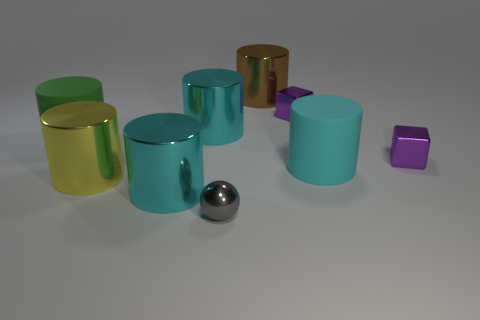Subtract all red blocks. How many cyan cylinders are left? 3 Subtract all brown cylinders. How many cylinders are left? 5 Subtract all large brown cylinders. How many cylinders are left? 5 Subtract all blue cylinders. Subtract all brown balls. How many cylinders are left? 6 Add 1 green objects. How many objects exist? 10 Subtract all cylinders. How many objects are left? 3 Add 2 small metal balls. How many small metal balls are left? 3 Add 4 small gray spheres. How many small gray spheres exist? 5 Subtract 0 brown balls. How many objects are left? 9 Subtract all large yellow metal cubes. Subtract all big brown shiny cylinders. How many objects are left? 8 